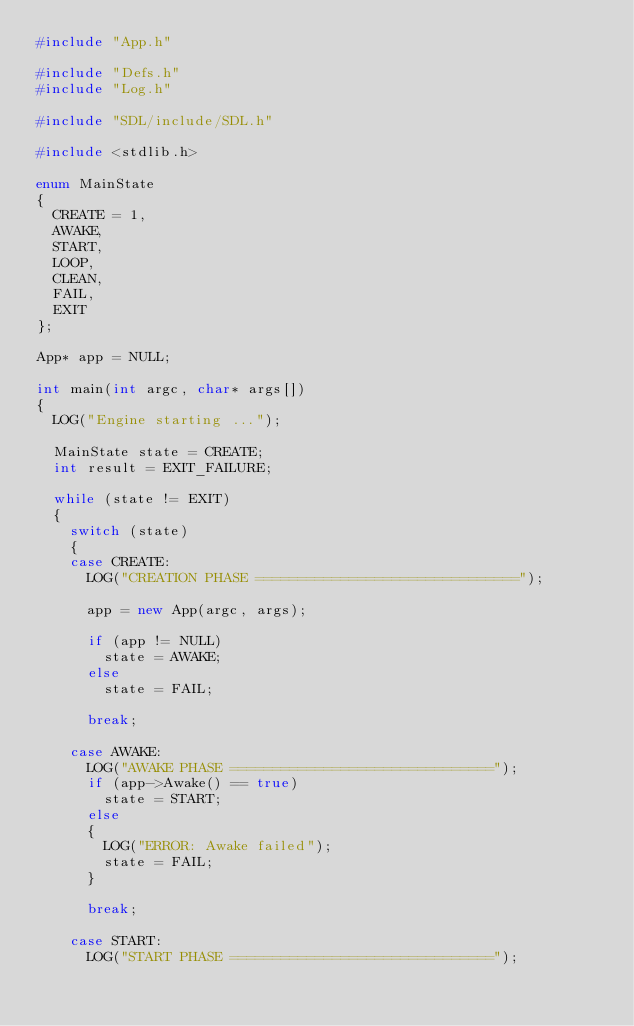<code> <loc_0><loc_0><loc_500><loc_500><_C++_>#include "App.h"

#include "Defs.h"
#include "Log.h"

#include "SDL/include/SDL.h"

#include <stdlib.h>

enum MainState
{
	CREATE = 1,
	AWAKE,
	START,
	LOOP,
	CLEAN,
	FAIL,
	EXIT
};

App* app = NULL;

int main(int argc, char* args[])
{
	LOG("Engine starting ...");

	MainState state = CREATE;
	int result = EXIT_FAILURE;

	while (state != EXIT)
	{
		switch (state)
		{
		case CREATE:
			LOG("CREATION PHASE ===============================");

			app = new App(argc, args);

			if (app != NULL)
				state = AWAKE;
			else
				state = FAIL;

			break;

		case AWAKE:
			LOG("AWAKE PHASE ===============================");
			if (app->Awake() == true)
				state = START;
			else
			{
				LOG("ERROR: Awake failed");
				state = FAIL;
			}

			break;

		case START:
			LOG("START PHASE ===============================");</code> 